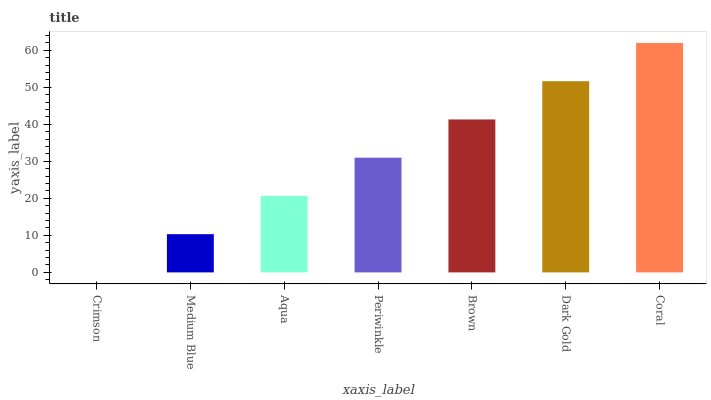Is Crimson the minimum?
Answer yes or no. Yes. Is Coral the maximum?
Answer yes or no. Yes. Is Medium Blue the minimum?
Answer yes or no. No. Is Medium Blue the maximum?
Answer yes or no. No. Is Medium Blue greater than Crimson?
Answer yes or no. Yes. Is Crimson less than Medium Blue?
Answer yes or no. Yes. Is Crimson greater than Medium Blue?
Answer yes or no. No. Is Medium Blue less than Crimson?
Answer yes or no. No. Is Periwinkle the high median?
Answer yes or no. Yes. Is Periwinkle the low median?
Answer yes or no. Yes. Is Crimson the high median?
Answer yes or no. No. Is Coral the low median?
Answer yes or no. No. 